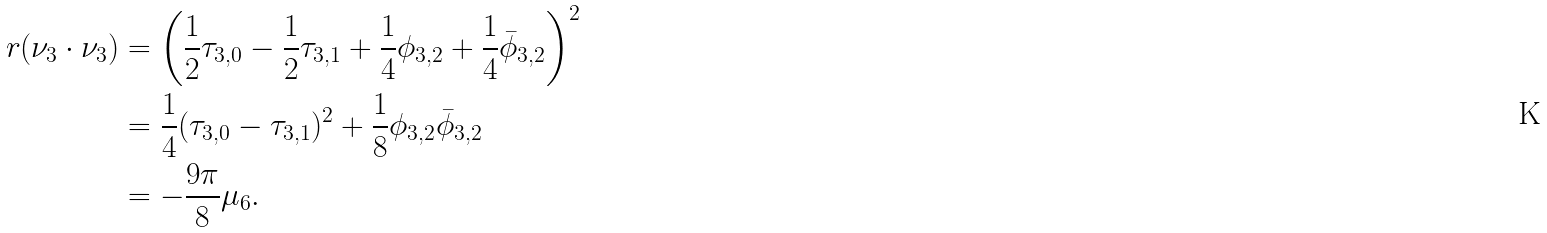Convert formula to latex. <formula><loc_0><loc_0><loc_500><loc_500>r ( \nu _ { 3 } \cdot \nu _ { 3 } ) & = \left ( \frac { 1 } { 2 } \tau _ { 3 , 0 } - \frac { 1 } { 2 } \tau _ { 3 , 1 } + \frac { 1 } { 4 } \phi _ { 3 , 2 } + \frac { 1 } { 4 } \bar { \phi } _ { 3 , 2 } \right ) ^ { 2 } \\ & = \frac { 1 } { 4 } ( \tau _ { 3 , 0 } - \tau _ { 3 , 1 } ) ^ { 2 } + \frac { 1 } { 8 } \phi _ { 3 , 2 } \bar { \phi } _ { 3 , 2 } \\ & = - \frac { 9 \pi } { 8 } \mu _ { 6 } .</formula> 